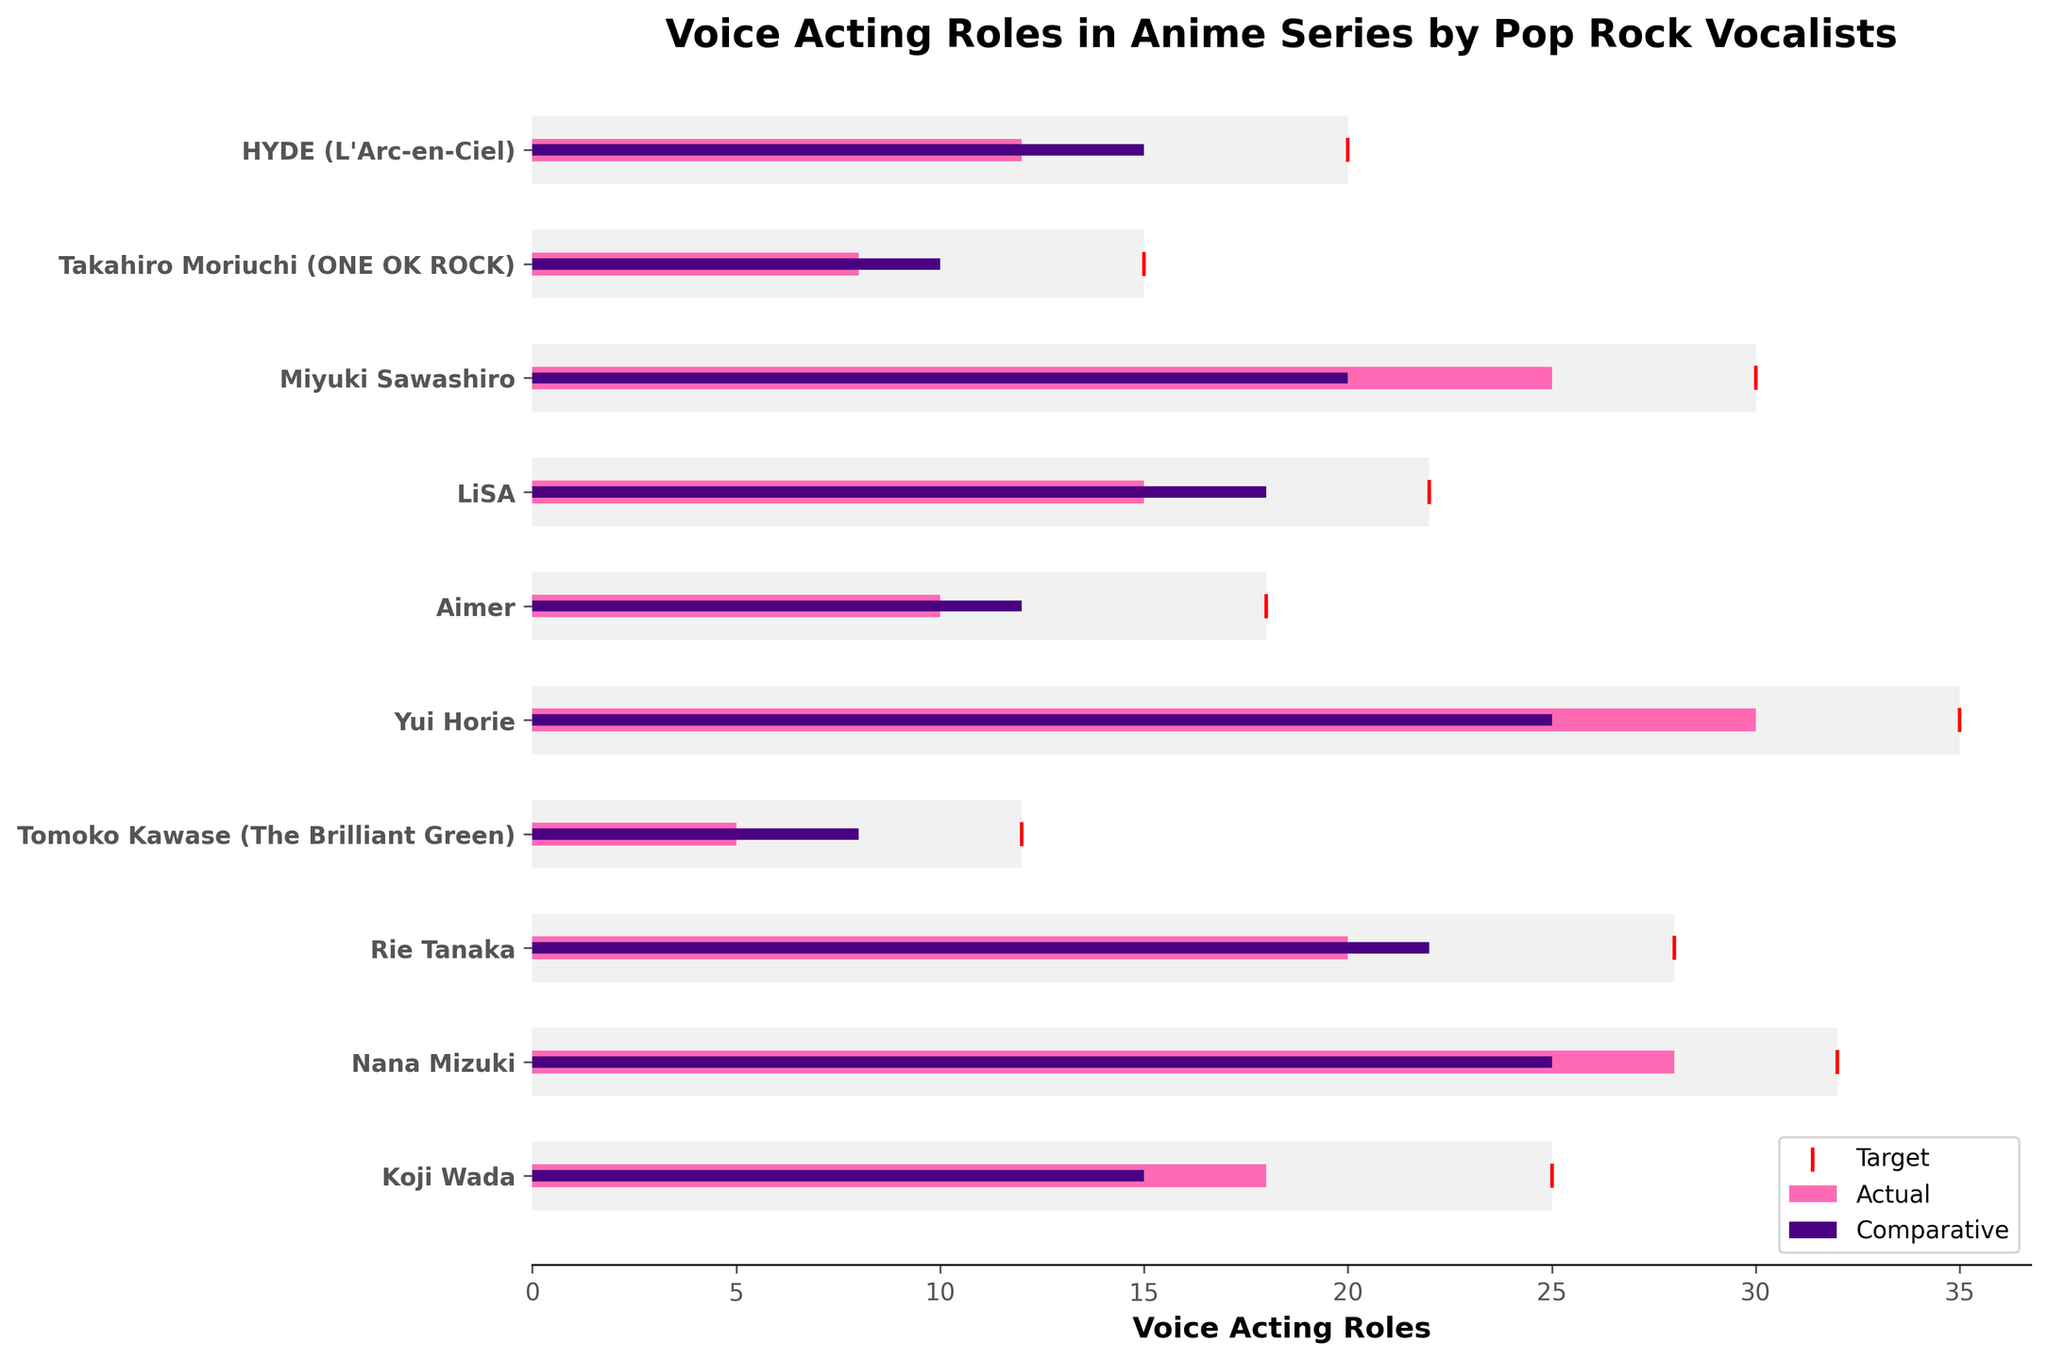What's the title of the figure? The title of the figure is typically placed at the top of the chart. Here it can be found at the top in bold font.
Answer: Voice Acting Roles in Anime Series by Pop Rock Vocalists How many voice acting roles has Koji Wada actually performed? To find this information, look at the "Actual" bar for Koji Wada and see where the end point aligns on the x-axis.
Answer: 18 Which vocalist has the highest target for voice acting roles? To identify this, compare the length of the light grey (Target) bars for all vocalists and find the longest one.
Answer: Yui Horie How many more roles does HYDE need to meet his target? Subtract HYDE's actual voice acting roles from his target roles.
Answer: 8 Who has performed more actual voice acting roles, LiSA or Aimer, and by how many? Compare the lengths of the pink (Actual) bars for both LiSA and Aimer and subtract the smaller value from the larger value.
Answer: LiSA by 5 What's the combined total of the target roles for Miyuki Sawashiro and Takahiro Moriuchi? Add Miyuki Sawashiro's and Takahiro Moriuchi's target voice acting roles together.
Answer: 45 Is Rie Tanaka’s comparative value higher, lower, or equal to her actual value? Compare the lengths of the purple (Comparative) and pink (Actual) bars for Rie Tanaka.
Answer: Higher Whose actual voice acting roles exceed their comparative value? Compare the pink (Actual) and purple (Comparative) bars for each vocalist to see whose actual is greater than their comparative.
Answer: Miyuki Sawashiro and Koji Wada Which vocalist has the smallest difference between their actual and target roles? Calculate the difference for each by subtracting actual roles from target roles and identify the smallest difference.
Answer: Nana Mizuki What’s the average number of actual voice acting roles performed by the listed vocalists? Sum all the actual voice acting roles and divide by the number of vocalists (10).
Answer: 17.1 